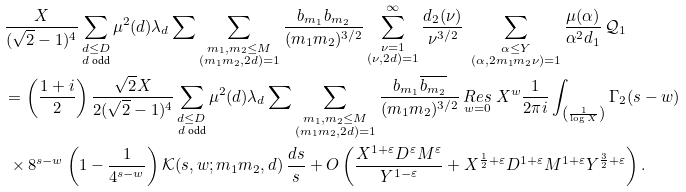<formula> <loc_0><loc_0><loc_500><loc_500>& \frac { X } { ( \sqrt { 2 } - 1 ) ^ { 4 } } \sum _ { \substack { d \leq D \\ d \text { odd} } } \mu ^ { 2 } ( d ) \lambda _ { d } \sum \sum _ { \substack { m _ { 1 } , m _ { 2 } \leq M \\ ( m _ { 1 } m _ { 2 } , 2 d ) = 1 } } \frac { b _ { m _ { 1 } } b _ { m _ { 2 } } } { ( m _ { 1 } m _ { 2 } ) ^ { 3 / 2 } } \sum _ { \substack { \nu = 1 \\ ( \nu , 2 d ) = 1 } } ^ { \infty } \frac { d _ { 2 } ( \nu ) } { \nu ^ { 3 / 2 } } \ \sum _ { \substack { \alpha \leq Y \\ ( \alpha , 2 m _ { 1 } m _ { 2 } \nu ) = 1 } } \frac { \mu ( \alpha ) } { \alpha ^ { 2 } d _ { 1 } } \, \mathcal { Q } _ { 1 } \\ & = \left ( \frac { 1 + i } { 2 } \right ) \frac { \sqrt { 2 } X } { 2 ( \sqrt { 2 } - 1 ) ^ { 4 } } \sum _ { \substack { d \leq D \\ d \text { odd} } } \mu ^ { 2 } ( d ) \lambda _ { d } \sum \sum _ { \substack { m _ { 1 } , m _ { 2 } \leq M \\ ( m _ { 1 } m _ { 2 } , 2 d ) = 1 } } \frac { b _ { m _ { 1 } } \overline { b _ { m _ { 2 } } } } { ( m _ { 1 } m _ { 2 } ) ^ { 3 / 2 } } \, \underset { w = 0 } { R e s } \ X ^ { w } \frac { 1 } { 2 \pi i } \int _ { \left ( \frac { 1 } { \log X } \right ) } \Gamma _ { 2 } ( s - w ) \\ & \ \times 8 ^ { s - w } \left ( 1 - \frac { 1 } { 4 ^ { s - w } } \right ) \mathcal { K } ( s , w ; m _ { 1 } m _ { 2 } , d ) \, \frac { d s } { s } + O \left ( \frac { X ^ { 1 + \varepsilon } D ^ { \varepsilon } M ^ { \varepsilon } } { Y ^ { 1 - \varepsilon } } + X ^ { \frac { 1 } { 2 } + \varepsilon } D ^ { 1 + \varepsilon } M ^ { 1 + \varepsilon } Y ^ { \frac { 3 } { 2 } + \varepsilon } \right ) .</formula> 